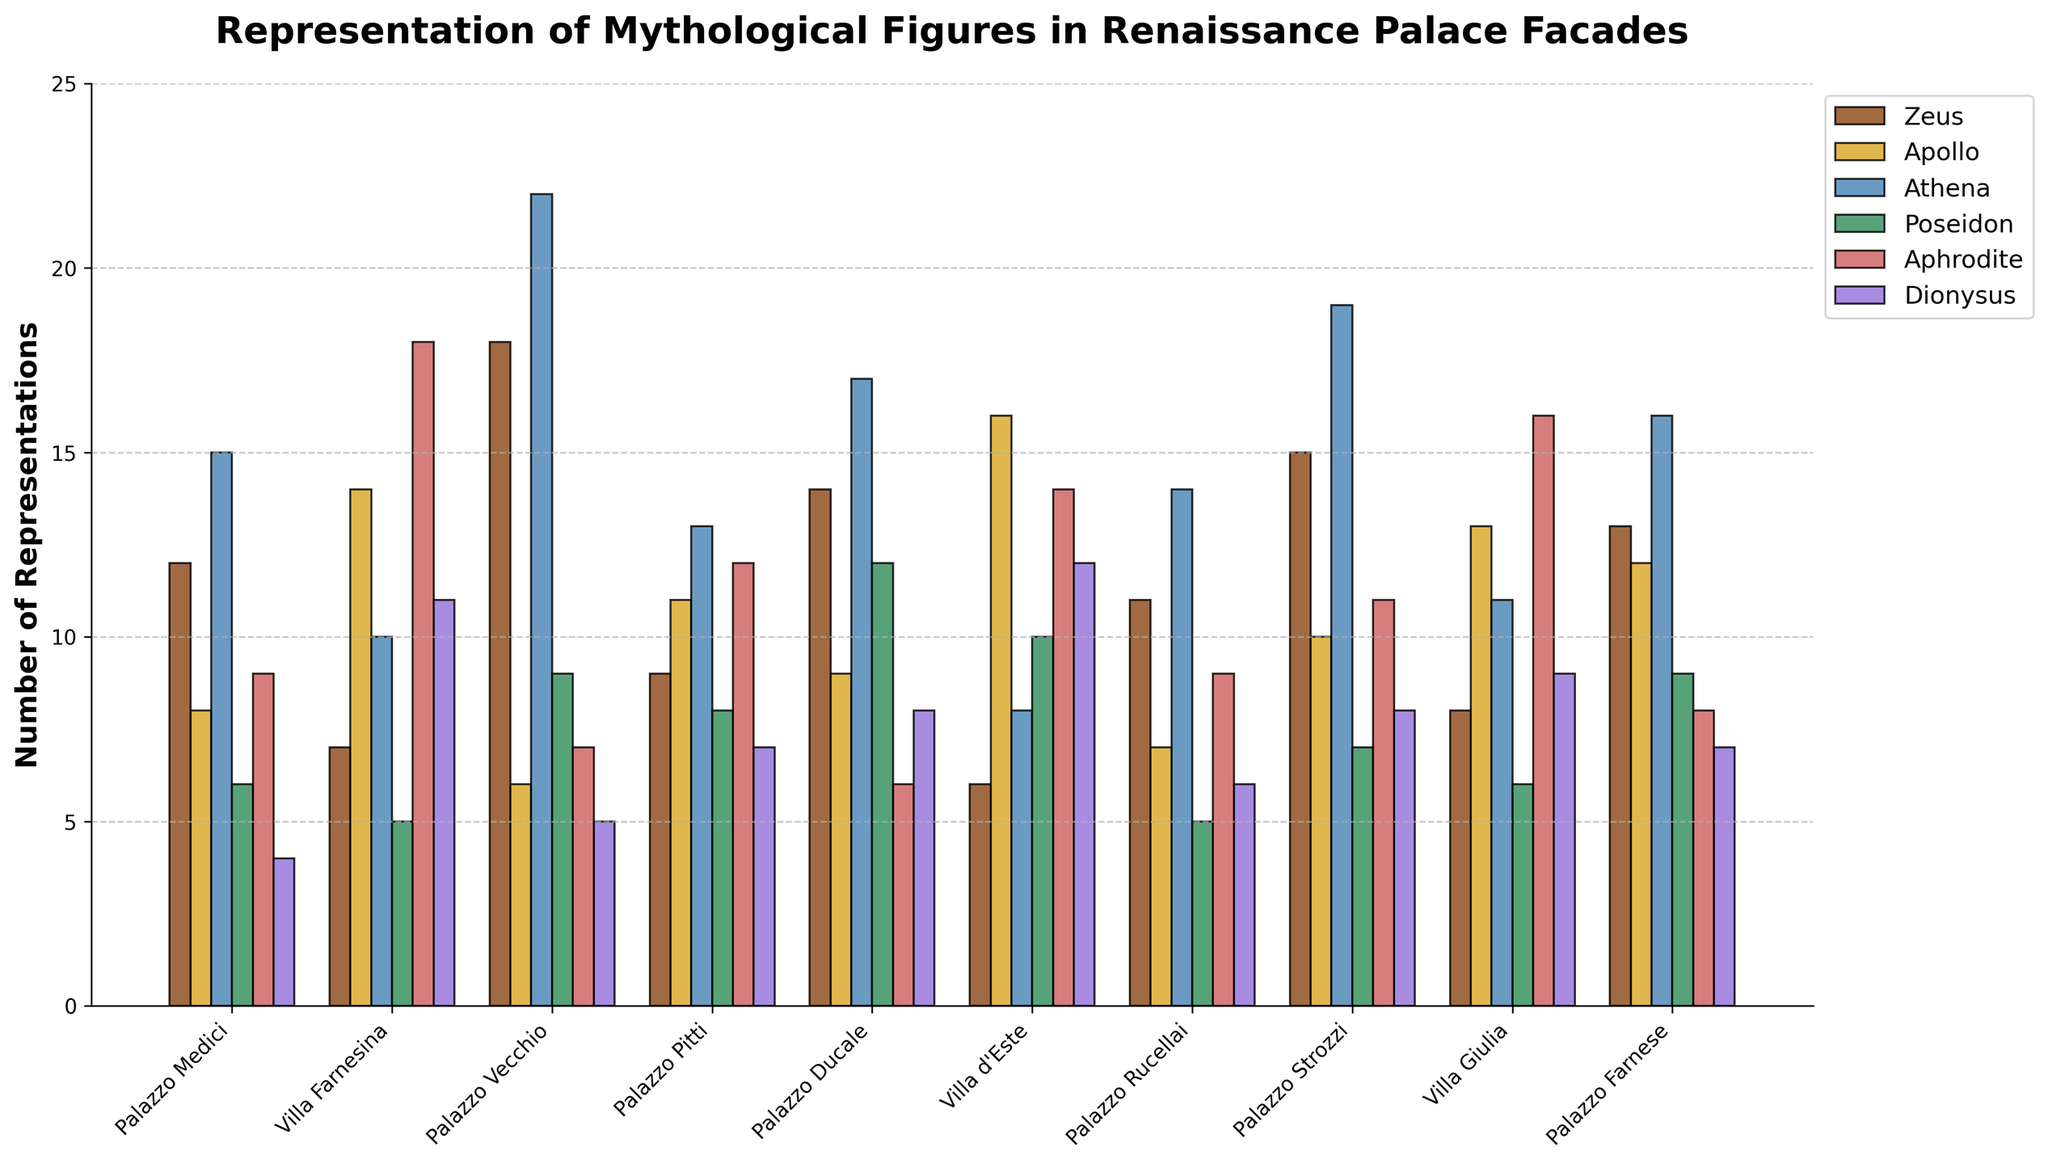Which palace has the highest number of Athena representations? Look at the heights of the bars representing Athena (blue color). Compare the heights of these bars across all palaces. The tallest bar indicates the palace with the highest representation.
Answer: Palazzo Vecchio By how many representations does Palazzo Strozzi's Dionysus exceed Palazzo Medici's Dionysus? Find the heights of the bars for Dionysus (purple color) in both palaces. Subtract the value of Palazzo Medici's Dionysus from Palazzo Strozzi's Dionysus.
Answer: 4 What is the total number of Zeus representations in Palazzo Rucellai and Villa Farnesina combined? Identify the heights of the bars for Zeus (brown color) in Palazzo Rucellai and Villa Farnesina, then add the two values together.
Answer: 18 Which palace has an equal number of Poseidon and Dionysus representations? Look for palaces where the bars for Poseidon (green color) and Dionysus (purple color) are of equal height.
Answer: Palazzo Rucellai What is the average number of Aphrodite representations across all palaces? Sum the heights of all the bars representing Aphrodite (pink color) across all palaces and divide by the number of palaces. The sum is (9 + 18 + 7 + 12 + 6 + 14 + 9 + 11 + 16 + 8) = 110, divided by 10 palaces, the average is 110 / 10 = 11
Answer: 11 Which palace has the lowest number of representations for Apollo and how many representations are depicted? Look for the shortest bar representing Apollo (yellow color) across all palaces. This shortest bar indicates the palace with the fewest Apollo representations.
Answer: Palazzo Vecchio with 6 Compare the number of Poseidon representations between Villa Farnesina and Villa d'Este, which one is higher and by how much? Identify the heights of the bars for Poseidon (green color) for both Villa Farnesina and Villa d'Este. Subtract the value of Villa Farnesina’s Poseidon from Villa d'Este's Poseidon.
Answer: Villa d'Este by 5 Which god has the most consistent number of representations across all palaces, and how many variations are there between the maximum and minimum representations? Examine the bars for each god across all palaces and find the god with the smallest range (difference between the highest and the lowest bar).
Answer: Dionysus, with a variation of 8 (12 - 4) What is the combined total of Athena and Poseidon representations for Palazzo Pitti? Find the heights of the bars for Athena (blue color) and Poseidon (green color) in Palazzo Pitti. Sum these two values.
Answer: 21 